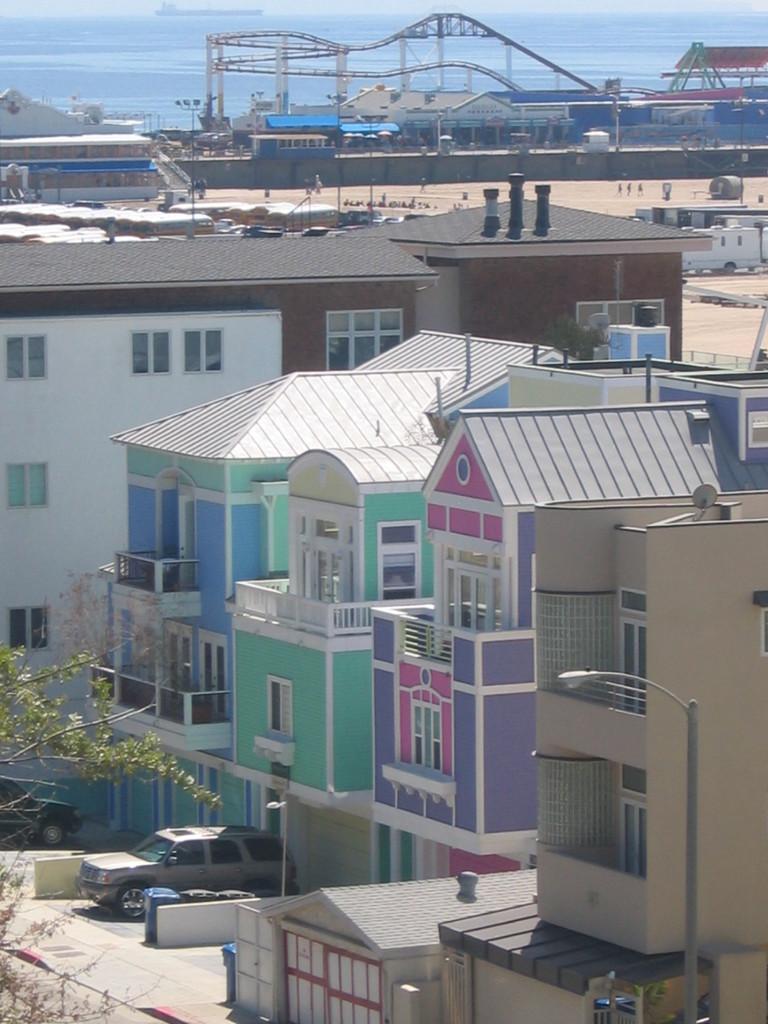Could you give a brief overview of what you see in this image? In this image in the foreground there are some buildings, pole, light, car, tree and in the background there are some poles, vehicles, walkway, wall, houses. And at the top of the image there is some water and on the water there is one boat. 